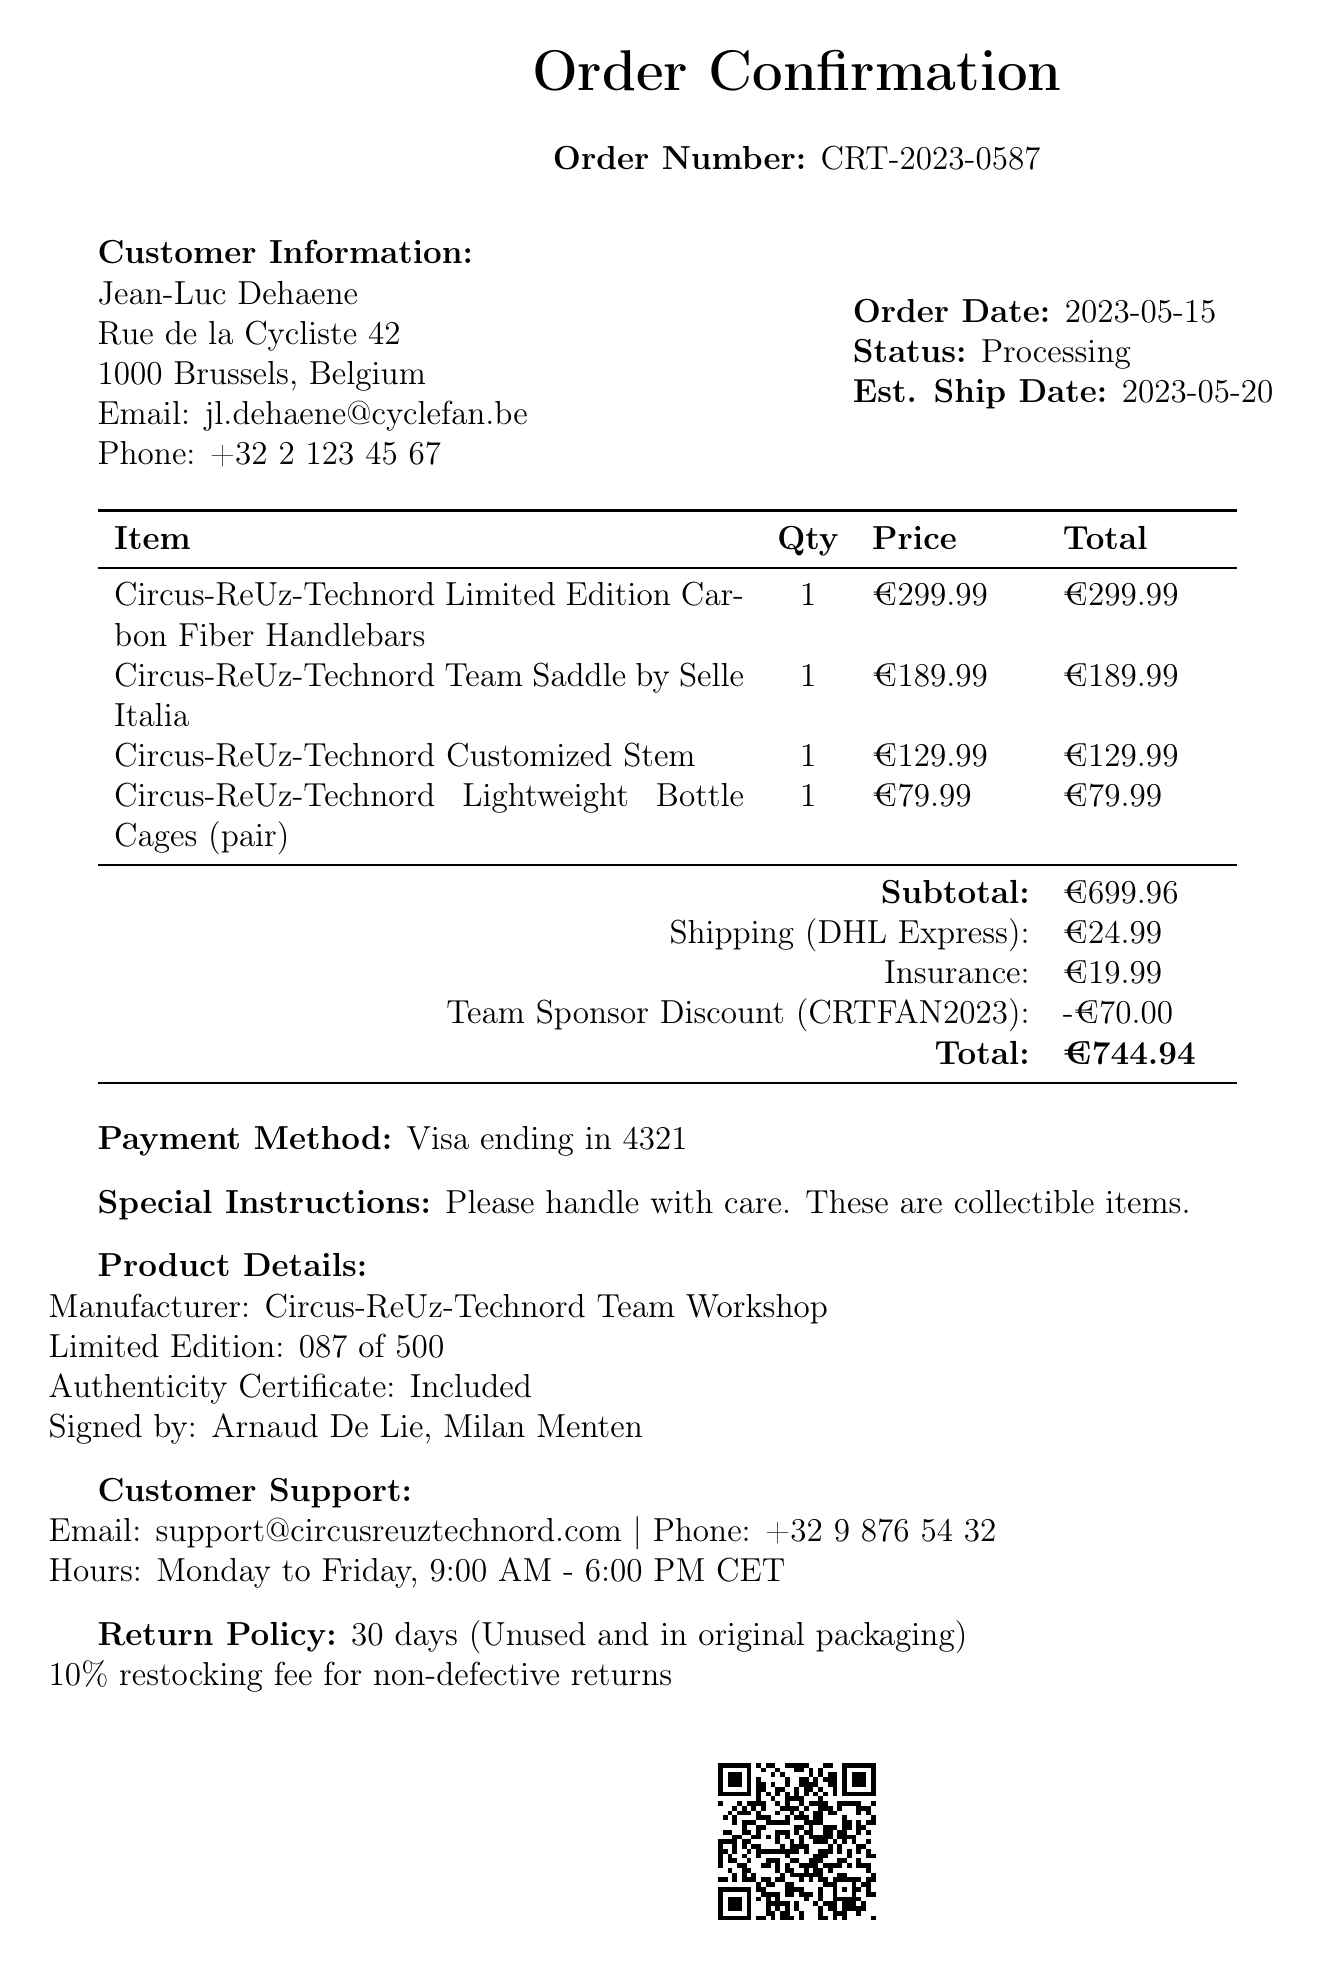What is the order number? The order number is a unique identifier for the transaction, listed as CRT-2023-0587 in the document.
Answer: CRT-2023-0587 Who is the customer? The customer's name is provided in the document, which is Jean-Luc Dehaene.
Answer: Jean-Luc Dehaene What is the estimated ship date? The estimated ship date is indicated in the document as the date when the order is expected to ship, which is 2023-05-20.
Answer: 2023-05-20 What is the subtotal amount? The subtotal is the sum of all the items purchased before any additional charges, noted in the document as €699.96.
Answer: €699.96 What is the shipping method? The shipping method is specified in the document indicating how the order will be delivered, which is DHL Express.
Answer: DHL Express What is the total cost after discounts? The total combines all costs and discounts in the document, culminating in the final amount due, which is €744.94.
Answer: €744.94 What is the return policy duration? The return policy duration is provided in the document, stating how long customers have to return items, which is 30 days.
Answer: 30 days Which items were ordered? The document lists all items purchased, specifically highlighting the Circus-ReUz-Technord components such as handlebars and saddle.
Answer: Circus-ReUz-Technord Limited Edition Carbon Fiber Handlebars, Circus-ReUz-Technord Team Saddle by Selle Italia, Circus-ReUz-Technord Customized Stem, Circus-ReUz-Technord Lightweight Bottle Cages (pair) Who signed the product? The document mentions the individuals whose signatures are included with the product details, indicating the signatories as Arnaud De Lie and Milan Menten.
Answer: Arnaud De Lie, Milan Menten 